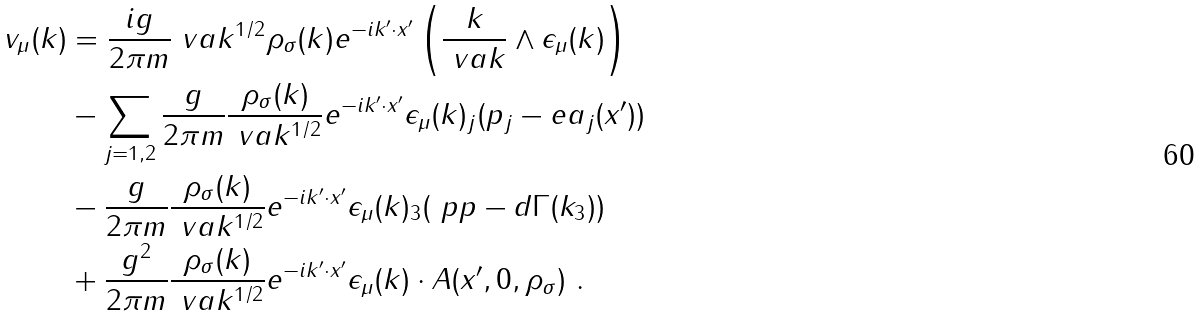Convert formula to latex. <formula><loc_0><loc_0><loc_500><loc_500>v _ { \mu } ( k ) & = \frac { i g } { 2 \pi m } \ v a k ^ { 1 / 2 } \rho _ { \sigma } ( k ) e ^ { - i k ^ { \prime } \cdot x ^ { \prime } } \left ( \frac { k } { \ v a k } \wedge \epsilon _ { \mu } ( k ) \right ) \\ & - \sum _ { j = 1 , 2 } \frac { g } { 2 \pi m } \frac { \rho _ { \sigma } ( k ) } { \ v a k ^ { 1 / 2 } } e ^ { - i k ^ { \prime } \cdot x ^ { \prime } } \epsilon _ { \mu } ( k ) _ { j } ( p _ { j } - e a _ { j } ( x ^ { \prime } ) ) \\ & - \frac { g } { 2 \pi m } \frac { \rho _ { \sigma } ( k ) } { \ v a k ^ { 1 / 2 } } e ^ { - i k ^ { \prime } \cdot x ^ { \prime } } \epsilon _ { \mu } ( k ) _ { 3 } ( \ p p - d \Gamma ( k _ { 3 } ) ) \\ & + \frac { g ^ { 2 } } { 2 \pi m } \frac { \rho _ { \sigma } ( k ) } { \ v a k ^ { 1 / 2 } } e ^ { - i k ^ { \prime } \cdot x ^ { \prime } } \epsilon _ { \mu } ( k ) \cdot A ( x ^ { \prime } , 0 , \rho _ { \sigma } ) \ .</formula> 